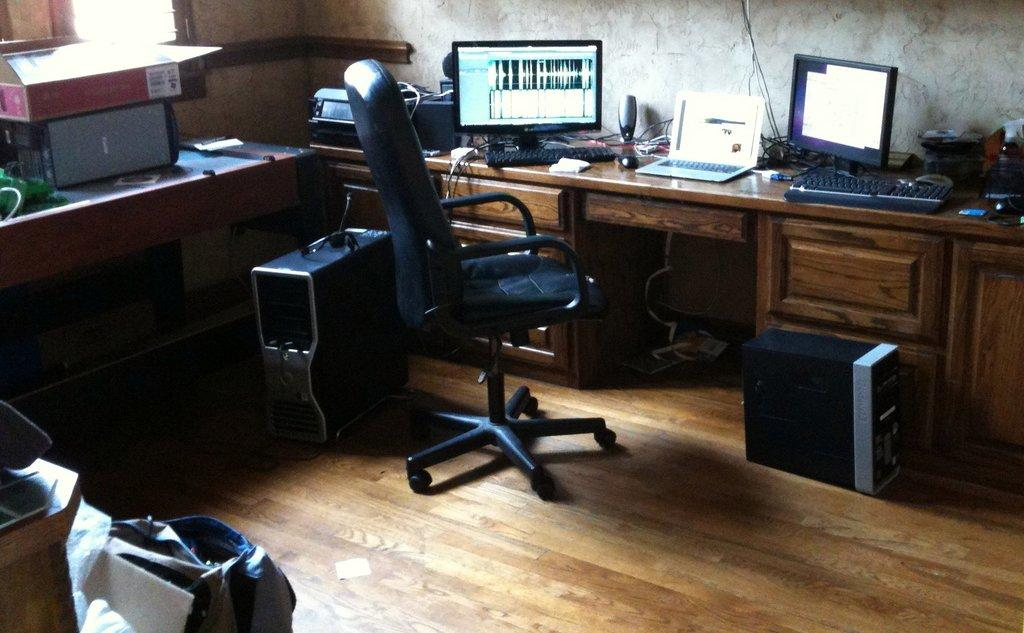What type of objects can be seen in the image? There are electronic gadgets in the image. Can you describe the furniture in the image? There is a chair and a wooden desk in the image. What type of fang can be seen on the snail in the image? There is no snail or fang present in the image. What type of shock can be seen coming from the electronic gadgets in the image? There is no indication of a shock or any electrical issues with the electronic gadgets in the image. 